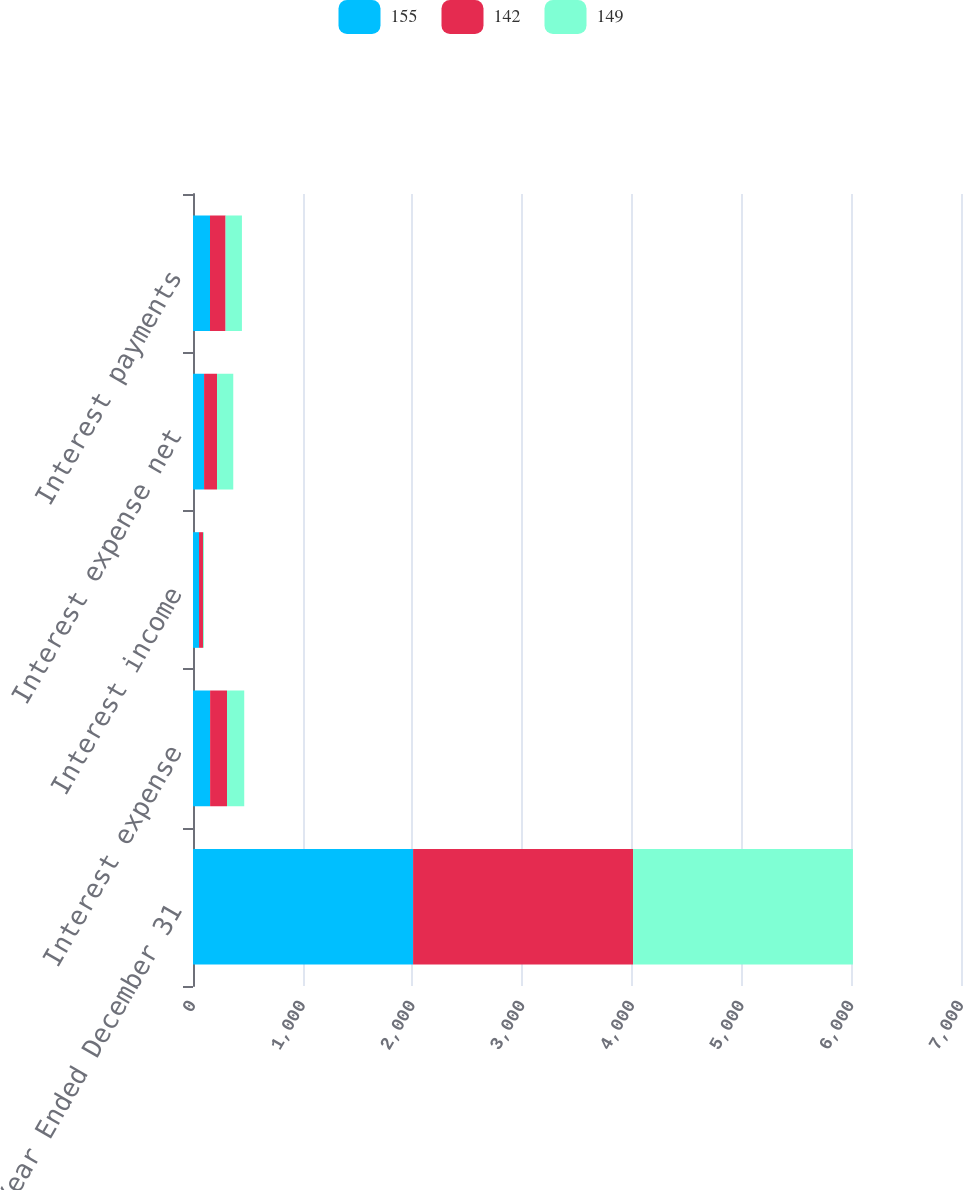<chart> <loc_0><loc_0><loc_500><loc_500><stacked_bar_chart><ecel><fcel>Year Ended December 31<fcel>Interest expense<fcel>Interest income<fcel>Interest expense net<fcel>Interest payments<nl><fcel>155<fcel>2006<fcel>156<fcel>55<fcel>101<fcel>155<nl><fcel>142<fcel>2005<fcel>154<fcel>36<fcel>118<fcel>142<nl><fcel>149<fcel>2004<fcel>157<fcel>9<fcel>148<fcel>149<nl></chart> 